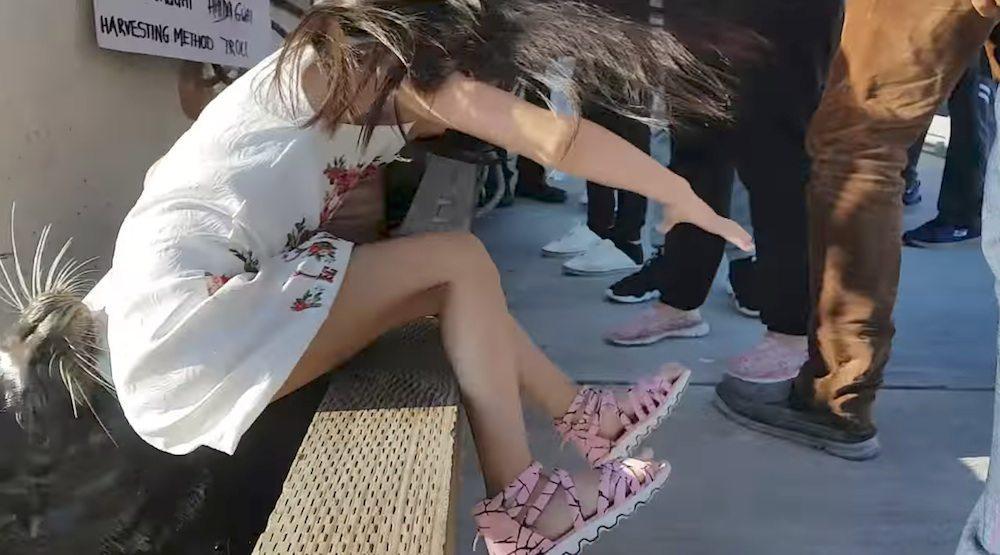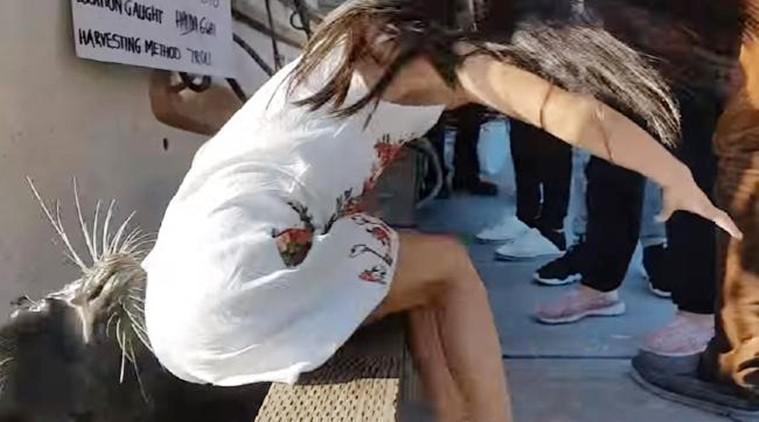The first image is the image on the left, the second image is the image on the right. For the images shown, is this caption "In at least one of the images the girl's shoes are not visible." true? Answer yes or no. Yes. 